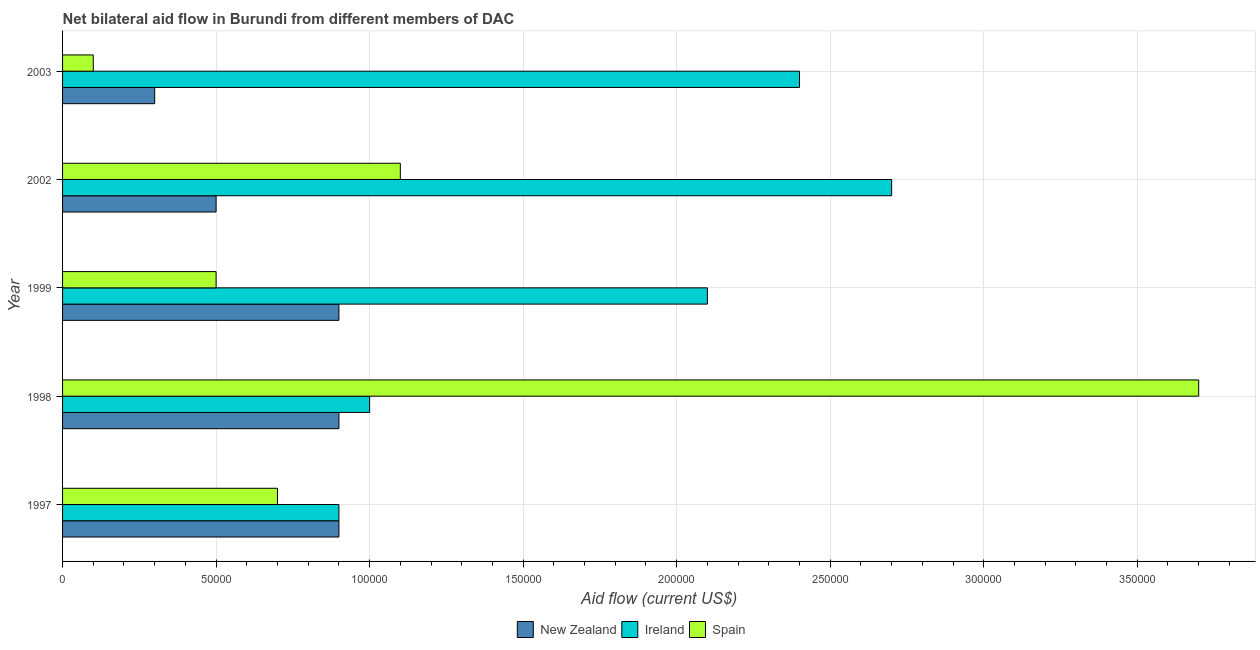How many groups of bars are there?
Your response must be concise. 5. How many bars are there on the 5th tick from the top?
Provide a short and direct response. 3. What is the label of the 3rd group of bars from the top?
Make the answer very short. 1999. In how many cases, is the number of bars for a given year not equal to the number of legend labels?
Your response must be concise. 0. What is the amount of aid provided by new zealand in 1997?
Provide a succinct answer. 9.00e+04. Across all years, what is the maximum amount of aid provided by spain?
Make the answer very short. 3.70e+05. Across all years, what is the minimum amount of aid provided by new zealand?
Provide a short and direct response. 3.00e+04. In which year was the amount of aid provided by ireland maximum?
Your answer should be compact. 2002. What is the total amount of aid provided by ireland in the graph?
Your answer should be very brief. 9.10e+05. What is the difference between the amount of aid provided by ireland in 1998 and that in 2002?
Keep it short and to the point. -1.70e+05. What is the average amount of aid provided by spain per year?
Your response must be concise. 1.22e+05. In the year 1997, what is the difference between the amount of aid provided by spain and amount of aid provided by ireland?
Offer a very short reply. -2.00e+04. In how many years, is the amount of aid provided by ireland greater than 190000 US$?
Ensure brevity in your answer.  3. What is the ratio of the amount of aid provided by ireland in 1998 to that in 2002?
Provide a short and direct response. 0.37. Is the difference between the amount of aid provided by new zealand in 1997 and 2003 greater than the difference between the amount of aid provided by ireland in 1997 and 2003?
Offer a terse response. Yes. What is the difference between the highest and the second highest amount of aid provided by ireland?
Offer a terse response. 3.00e+04. What is the difference between the highest and the lowest amount of aid provided by spain?
Offer a very short reply. 3.60e+05. In how many years, is the amount of aid provided by spain greater than the average amount of aid provided by spain taken over all years?
Your answer should be compact. 1. Is the sum of the amount of aid provided by new zealand in 1997 and 2002 greater than the maximum amount of aid provided by spain across all years?
Offer a very short reply. No. What does the 2nd bar from the bottom in 1999 represents?
Provide a succinct answer. Ireland. Is it the case that in every year, the sum of the amount of aid provided by new zealand and amount of aid provided by ireland is greater than the amount of aid provided by spain?
Provide a succinct answer. No. How many bars are there?
Your response must be concise. 15. Are all the bars in the graph horizontal?
Your answer should be compact. Yes. What is the title of the graph?
Your response must be concise. Net bilateral aid flow in Burundi from different members of DAC. Does "Self-employed" appear as one of the legend labels in the graph?
Make the answer very short. No. What is the label or title of the Y-axis?
Give a very brief answer. Year. What is the Aid flow (current US$) in Spain in 1997?
Your answer should be very brief. 7.00e+04. What is the Aid flow (current US$) of Ireland in 1998?
Keep it short and to the point. 1.00e+05. What is the Aid flow (current US$) of New Zealand in 1999?
Your answer should be compact. 9.00e+04. What is the Aid flow (current US$) in Spain in 1999?
Provide a short and direct response. 5.00e+04. What is the Aid flow (current US$) in Spain in 2002?
Your response must be concise. 1.10e+05. What is the Aid flow (current US$) of New Zealand in 2003?
Provide a succinct answer. 3.00e+04. What is the Aid flow (current US$) of Spain in 2003?
Offer a terse response. 10000. Across all years, what is the maximum Aid flow (current US$) of New Zealand?
Provide a short and direct response. 9.00e+04. Across all years, what is the minimum Aid flow (current US$) of Spain?
Your response must be concise. 10000. What is the total Aid flow (current US$) of New Zealand in the graph?
Make the answer very short. 3.50e+05. What is the total Aid flow (current US$) of Ireland in the graph?
Your response must be concise. 9.10e+05. What is the total Aid flow (current US$) in Spain in the graph?
Offer a very short reply. 6.10e+05. What is the difference between the Aid flow (current US$) of New Zealand in 1997 and that in 1998?
Your answer should be very brief. 0. What is the difference between the Aid flow (current US$) in Ireland in 1997 and that in 1998?
Provide a short and direct response. -10000. What is the difference between the Aid flow (current US$) in Spain in 1997 and that in 1998?
Provide a succinct answer. -3.00e+05. What is the difference between the Aid flow (current US$) in Ireland in 1997 and that in 2002?
Your answer should be compact. -1.80e+05. What is the difference between the Aid flow (current US$) in Spain in 1997 and that in 2002?
Keep it short and to the point. -4.00e+04. What is the difference between the Aid flow (current US$) of New Zealand in 1997 and that in 2003?
Make the answer very short. 6.00e+04. What is the difference between the Aid flow (current US$) of Ireland in 1997 and that in 2003?
Your answer should be very brief. -1.50e+05. What is the difference between the Aid flow (current US$) of New Zealand in 1998 and that in 2002?
Provide a short and direct response. 4.00e+04. What is the difference between the Aid flow (current US$) of Ireland in 1998 and that in 2002?
Provide a succinct answer. -1.70e+05. What is the difference between the Aid flow (current US$) of New Zealand in 1998 and that in 2003?
Keep it short and to the point. 6.00e+04. What is the difference between the Aid flow (current US$) in Ireland in 1998 and that in 2003?
Offer a terse response. -1.40e+05. What is the difference between the Aid flow (current US$) of Spain in 1999 and that in 2002?
Offer a terse response. -6.00e+04. What is the difference between the Aid flow (current US$) of New Zealand in 1999 and that in 2003?
Offer a very short reply. 6.00e+04. What is the difference between the Aid flow (current US$) of Ireland in 1999 and that in 2003?
Your response must be concise. -3.00e+04. What is the difference between the Aid flow (current US$) of New Zealand in 2002 and that in 2003?
Offer a terse response. 2.00e+04. What is the difference between the Aid flow (current US$) in Ireland in 2002 and that in 2003?
Your answer should be very brief. 3.00e+04. What is the difference between the Aid flow (current US$) in Spain in 2002 and that in 2003?
Ensure brevity in your answer.  1.00e+05. What is the difference between the Aid flow (current US$) of New Zealand in 1997 and the Aid flow (current US$) of Spain in 1998?
Your response must be concise. -2.80e+05. What is the difference between the Aid flow (current US$) in Ireland in 1997 and the Aid flow (current US$) in Spain in 1998?
Keep it short and to the point. -2.80e+05. What is the difference between the Aid flow (current US$) of New Zealand in 1997 and the Aid flow (current US$) of Spain in 1999?
Ensure brevity in your answer.  4.00e+04. What is the difference between the Aid flow (current US$) of Ireland in 1997 and the Aid flow (current US$) of Spain in 2002?
Offer a very short reply. -2.00e+04. What is the difference between the Aid flow (current US$) in New Zealand in 1997 and the Aid flow (current US$) in Ireland in 2003?
Keep it short and to the point. -1.50e+05. What is the difference between the Aid flow (current US$) of Ireland in 1997 and the Aid flow (current US$) of Spain in 2003?
Offer a very short reply. 8.00e+04. What is the difference between the Aid flow (current US$) of New Zealand in 1998 and the Aid flow (current US$) of Ireland in 1999?
Your response must be concise. -1.20e+05. What is the difference between the Aid flow (current US$) in New Zealand in 1998 and the Aid flow (current US$) in Ireland in 2002?
Provide a short and direct response. -1.80e+05. What is the difference between the Aid flow (current US$) of New Zealand in 1998 and the Aid flow (current US$) of Spain in 2002?
Ensure brevity in your answer.  -2.00e+04. What is the difference between the Aid flow (current US$) in Ireland in 1998 and the Aid flow (current US$) in Spain in 2002?
Keep it short and to the point. -10000. What is the difference between the Aid flow (current US$) in New Zealand in 1998 and the Aid flow (current US$) in Ireland in 2003?
Make the answer very short. -1.50e+05. What is the difference between the Aid flow (current US$) in New Zealand in 1998 and the Aid flow (current US$) in Spain in 2003?
Your answer should be very brief. 8.00e+04. What is the difference between the Aid flow (current US$) of Ireland in 1998 and the Aid flow (current US$) of Spain in 2003?
Your response must be concise. 9.00e+04. What is the difference between the Aid flow (current US$) of New Zealand in 1999 and the Aid flow (current US$) of Ireland in 2002?
Your answer should be compact. -1.80e+05. What is the difference between the Aid flow (current US$) in Ireland in 1999 and the Aid flow (current US$) in Spain in 2002?
Provide a succinct answer. 1.00e+05. What is the difference between the Aid flow (current US$) in New Zealand in 1999 and the Aid flow (current US$) in Ireland in 2003?
Your answer should be compact. -1.50e+05. What is the difference between the Aid flow (current US$) in New Zealand in 1999 and the Aid flow (current US$) in Spain in 2003?
Make the answer very short. 8.00e+04. What is the difference between the Aid flow (current US$) in Ireland in 2002 and the Aid flow (current US$) in Spain in 2003?
Your answer should be very brief. 2.60e+05. What is the average Aid flow (current US$) in New Zealand per year?
Your answer should be very brief. 7.00e+04. What is the average Aid flow (current US$) of Ireland per year?
Keep it short and to the point. 1.82e+05. What is the average Aid flow (current US$) of Spain per year?
Provide a short and direct response. 1.22e+05. In the year 1997, what is the difference between the Aid flow (current US$) of Ireland and Aid flow (current US$) of Spain?
Offer a very short reply. 2.00e+04. In the year 1998, what is the difference between the Aid flow (current US$) in New Zealand and Aid flow (current US$) in Spain?
Offer a terse response. -2.80e+05. In the year 1999, what is the difference between the Aid flow (current US$) of New Zealand and Aid flow (current US$) of Ireland?
Provide a short and direct response. -1.20e+05. In the year 1999, what is the difference between the Aid flow (current US$) in New Zealand and Aid flow (current US$) in Spain?
Your response must be concise. 4.00e+04. In the year 1999, what is the difference between the Aid flow (current US$) in Ireland and Aid flow (current US$) in Spain?
Your answer should be compact. 1.60e+05. In the year 2002, what is the difference between the Aid flow (current US$) of New Zealand and Aid flow (current US$) of Ireland?
Keep it short and to the point. -2.20e+05. In the year 2002, what is the difference between the Aid flow (current US$) of New Zealand and Aid flow (current US$) of Spain?
Your answer should be compact. -6.00e+04. In the year 2003, what is the difference between the Aid flow (current US$) of New Zealand and Aid flow (current US$) of Spain?
Your response must be concise. 2.00e+04. In the year 2003, what is the difference between the Aid flow (current US$) of Ireland and Aid flow (current US$) of Spain?
Ensure brevity in your answer.  2.30e+05. What is the ratio of the Aid flow (current US$) of New Zealand in 1997 to that in 1998?
Your response must be concise. 1. What is the ratio of the Aid flow (current US$) of Spain in 1997 to that in 1998?
Keep it short and to the point. 0.19. What is the ratio of the Aid flow (current US$) of Ireland in 1997 to that in 1999?
Your response must be concise. 0.43. What is the ratio of the Aid flow (current US$) of Spain in 1997 to that in 2002?
Ensure brevity in your answer.  0.64. What is the ratio of the Aid flow (current US$) in Ireland in 1998 to that in 1999?
Provide a succinct answer. 0.48. What is the ratio of the Aid flow (current US$) of Ireland in 1998 to that in 2002?
Offer a very short reply. 0.37. What is the ratio of the Aid flow (current US$) of Spain in 1998 to that in 2002?
Make the answer very short. 3.36. What is the ratio of the Aid flow (current US$) in New Zealand in 1998 to that in 2003?
Your response must be concise. 3. What is the ratio of the Aid flow (current US$) of Ireland in 1998 to that in 2003?
Give a very brief answer. 0.42. What is the ratio of the Aid flow (current US$) of Spain in 1998 to that in 2003?
Ensure brevity in your answer.  37. What is the ratio of the Aid flow (current US$) in New Zealand in 1999 to that in 2002?
Provide a succinct answer. 1.8. What is the ratio of the Aid flow (current US$) in Spain in 1999 to that in 2002?
Offer a very short reply. 0.45. What is the ratio of the Aid flow (current US$) in New Zealand in 1999 to that in 2003?
Provide a short and direct response. 3. What is the ratio of the Aid flow (current US$) in Ireland in 1999 to that in 2003?
Provide a succinct answer. 0.88. What is the ratio of the Aid flow (current US$) of Spain in 1999 to that in 2003?
Provide a short and direct response. 5. What is the ratio of the Aid flow (current US$) of New Zealand in 2002 to that in 2003?
Your answer should be very brief. 1.67. What is the difference between the highest and the second highest Aid flow (current US$) of Spain?
Ensure brevity in your answer.  2.60e+05. What is the difference between the highest and the lowest Aid flow (current US$) of Ireland?
Ensure brevity in your answer.  1.80e+05. What is the difference between the highest and the lowest Aid flow (current US$) of Spain?
Provide a short and direct response. 3.60e+05. 